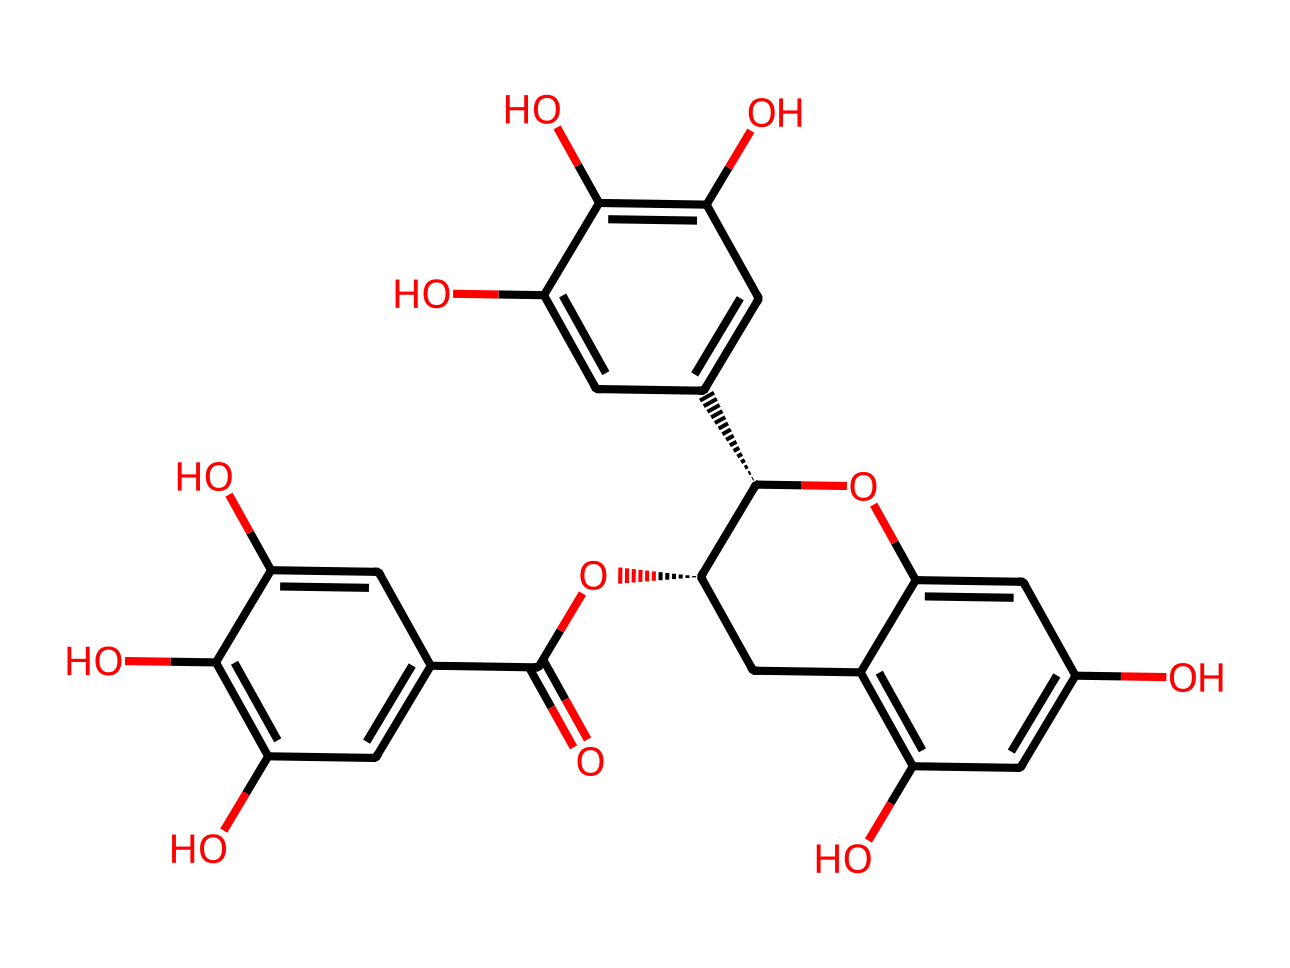How many carbon atoms are present in the structure? To answer this question, we count the carbon atoms in the provided SMILES representation. Each 'C' symbol in the SMILES, as well as the implicit carbons in cyclic structures and other groups, contributes to the total count. Upon careful examination, there are 22 carbon atoms.
Answer: 22 How many hydroxyl (-OH) groups are in the molecule? The hydroxyl groups are indicated by the 'O' adjacent to carbon in the structure. Counting the number of occurrences of 'O' within the chemical structure, we determine that there are six hydroxyl groups present in this compound.
Answer: 6 What is the molecular formula of epigallocatechin gallate based on its structure? To derive the molecular formula, we assemble the total counts of each type of atom from the SMILES representation. After computing the quantities of carbon, hydrogen, and oxygen, the molecular formula is identified as C22H18O11.
Answer: C22H18O11 Is epigallocatechin gallate a flavonoid? Considering the information conveyed by the structure, the presence of multiple hydroxyl groups on aromatic rings suggests it belongs to the flavonoid class, which is characterized by the presence of these functional groups.
Answer: Yes Which type of antioxidant activity is primarily associated with epigallocatechin gallate? Examining the structure and literature on this compound, we find that its antioxidant activity is particularly linked to free radical scavenging capabilities, attributed mainly to its hydroxyl groups' reactivity.
Answer: Free radical scavenging What makes epigallocatechin gallate more effective as an antioxidant compared to other similar compounds? Analyzing its structure reveals that the specific arrangement of multiple hydroxyl groups allows for enhanced electron donation and stabilization of radical species, making it particularly effective compared to other compounds with fewer or less strategically positioned hydroxyls.
Answer: Hydroxyl arrangement 